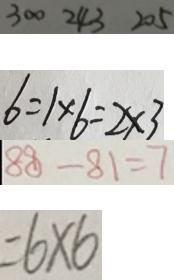Convert formula to latex. <formula><loc_0><loc_0><loc_500><loc_500>3 0 0 2 4 3 2 0 5 
 6 = 1 \times 6 = 2 \times 3 
 8 8 - 8 1 = 7 
 = 6 \times 6</formula> 